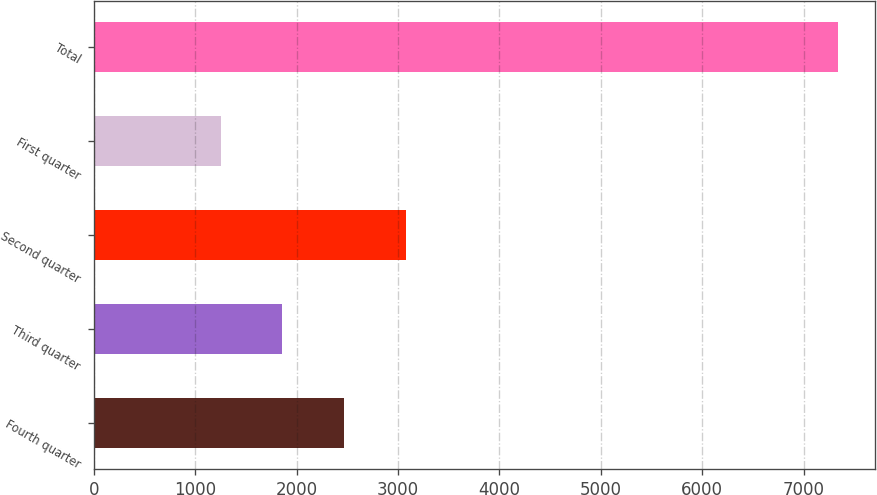<chart> <loc_0><loc_0><loc_500><loc_500><bar_chart><fcel>Fourth quarter<fcel>Third quarter<fcel>Second quarter<fcel>First quarter<fcel>Total<nl><fcel>2468.8<fcel>1859.9<fcel>3077.7<fcel>1251<fcel>7340<nl></chart> 